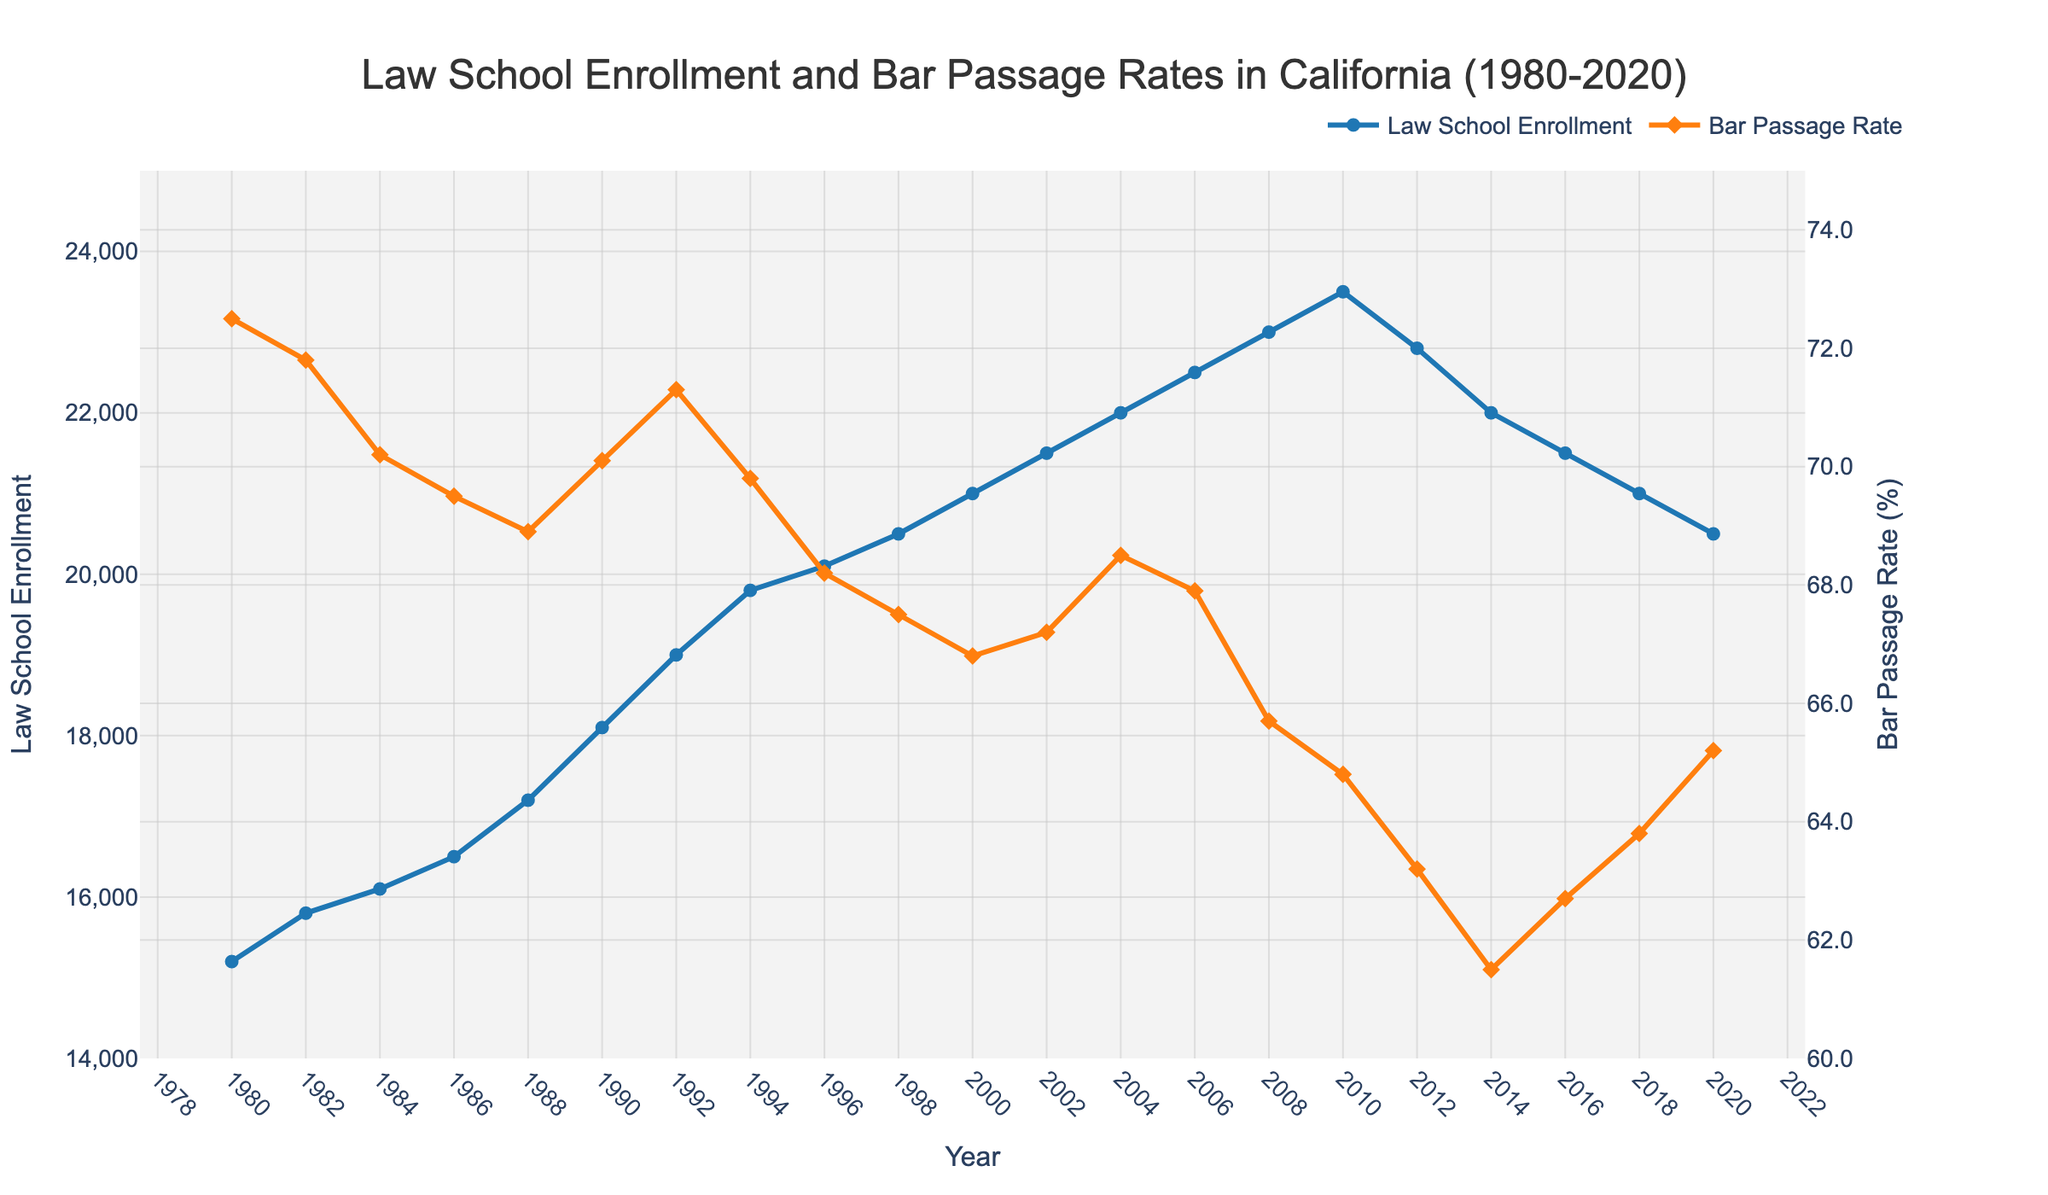What is the general trend of law school enrollment from 1980 to 2020? The plot shows a steady increase in law school enrollment from 1980 to 2010, after which enrollment starts to decline until 2020.
Answer: Increasing until 2010, then decreasing How did the bar passage rate change from 1980 to 2020? The bar passage rate generally decreased from 1980 to 2014, with a slight recovery from 2014 to 2020.
Answer: Generally decreasing, then slight recovery What was the bar passage rate in 1988, and how does it compare to the rate in 2020? The bar passage rate in 1988 was 68.9%, and in 2020 it was 65.2%. The rate decreased by 3.7 percentage points over this period.
Answer: 68.9% in 1988, 65.2% in 2020, decreased by 3.7 percentage points In which year did the law school enrollment reach its peak, and what was the enrollment count? Law school enrollment peaked in 2010 with an enrollment count of 23,500 students.
Answer: 2010, 23,500 students What is the difference in bar passage rates between 2008 and 2018? The bar passage rate in 2008 was 65.7%, and in 2018 it was 63.8%. The difference is 65.7% - 63.8% = 1.9 percentage points.
Answer: 1.9 percentage points Compare the trend of law school enrollment and bar passage rate between 2000 and 2010. Between 2000 and 2010, law school enrollment increased steadily from 21,000 to 23,500, while the bar passage rate showed a decreasing trend from 66.8% to 64.8%.
Answer: Enrollment increased, passage rate decreased What was the enrollment in 2014, and how much did it change by 2018? Enrollment in 2014 was 22,000, and by 2018 it decreased to 21,000, resulting in a change of 22,000 - 21,000 = 1,000.
Answer: 1,000 decrease Given the trends observed, what could be a possible correlation between law school enrollment and bar passage rates over the years? Generally, as law school enrollment increased, the bar passage rates decreased. However, the trends start to diverge from 2010 onward when both metrics decline.
Answer: Negative correlation until 2010, then both decline 